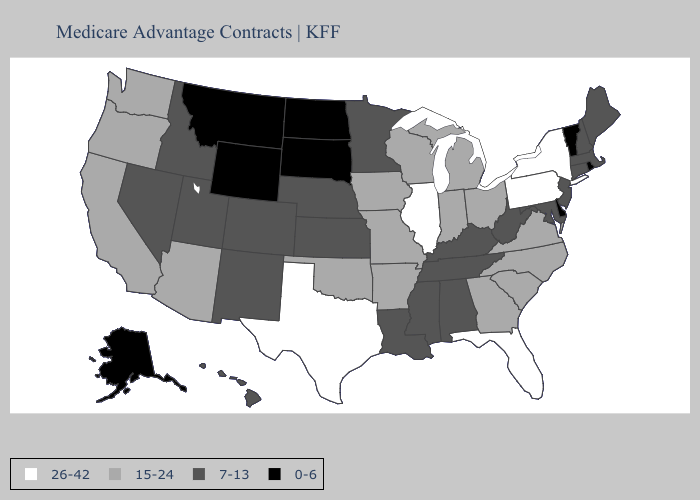Name the states that have a value in the range 15-24?
Short answer required. Arkansas, Arizona, California, Georgia, Iowa, Indiana, Michigan, Missouri, North Carolina, Ohio, Oklahoma, Oregon, South Carolina, Virginia, Washington, Wisconsin. What is the highest value in states that border Texas?
Write a very short answer. 15-24. Does Montana have the lowest value in the West?
Give a very brief answer. Yes. Name the states that have a value in the range 7-13?
Write a very short answer. Alabama, Colorado, Connecticut, Hawaii, Idaho, Kansas, Kentucky, Louisiana, Massachusetts, Maryland, Maine, Minnesota, Mississippi, Nebraska, New Hampshire, New Jersey, New Mexico, Nevada, Tennessee, Utah, West Virginia. Which states hav the highest value in the South?
Answer briefly. Florida, Texas. Which states have the highest value in the USA?
Write a very short answer. Florida, Illinois, New York, Pennsylvania, Texas. Name the states that have a value in the range 15-24?
Be succinct. Arkansas, Arizona, California, Georgia, Iowa, Indiana, Michigan, Missouri, North Carolina, Ohio, Oklahoma, Oregon, South Carolina, Virginia, Washington, Wisconsin. What is the highest value in the Northeast ?
Quick response, please. 26-42. Name the states that have a value in the range 7-13?
Give a very brief answer. Alabama, Colorado, Connecticut, Hawaii, Idaho, Kansas, Kentucky, Louisiana, Massachusetts, Maryland, Maine, Minnesota, Mississippi, Nebraska, New Hampshire, New Jersey, New Mexico, Nevada, Tennessee, Utah, West Virginia. How many symbols are there in the legend?
Answer briefly. 4. Among the states that border Tennessee , which have the lowest value?
Keep it brief. Alabama, Kentucky, Mississippi. What is the highest value in the South ?
Concise answer only. 26-42. Which states have the lowest value in the USA?
Answer briefly. Alaska, Delaware, Montana, North Dakota, Rhode Island, South Dakota, Vermont, Wyoming. Name the states that have a value in the range 0-6?
Concise answer only. Alaska, Delaware, Montana, North Dakota, Rhode Island, South Dakota, Vermont, Wyoming. Among the states that border Indiana , which have the highest value?
Quick response, please. Illinois. 